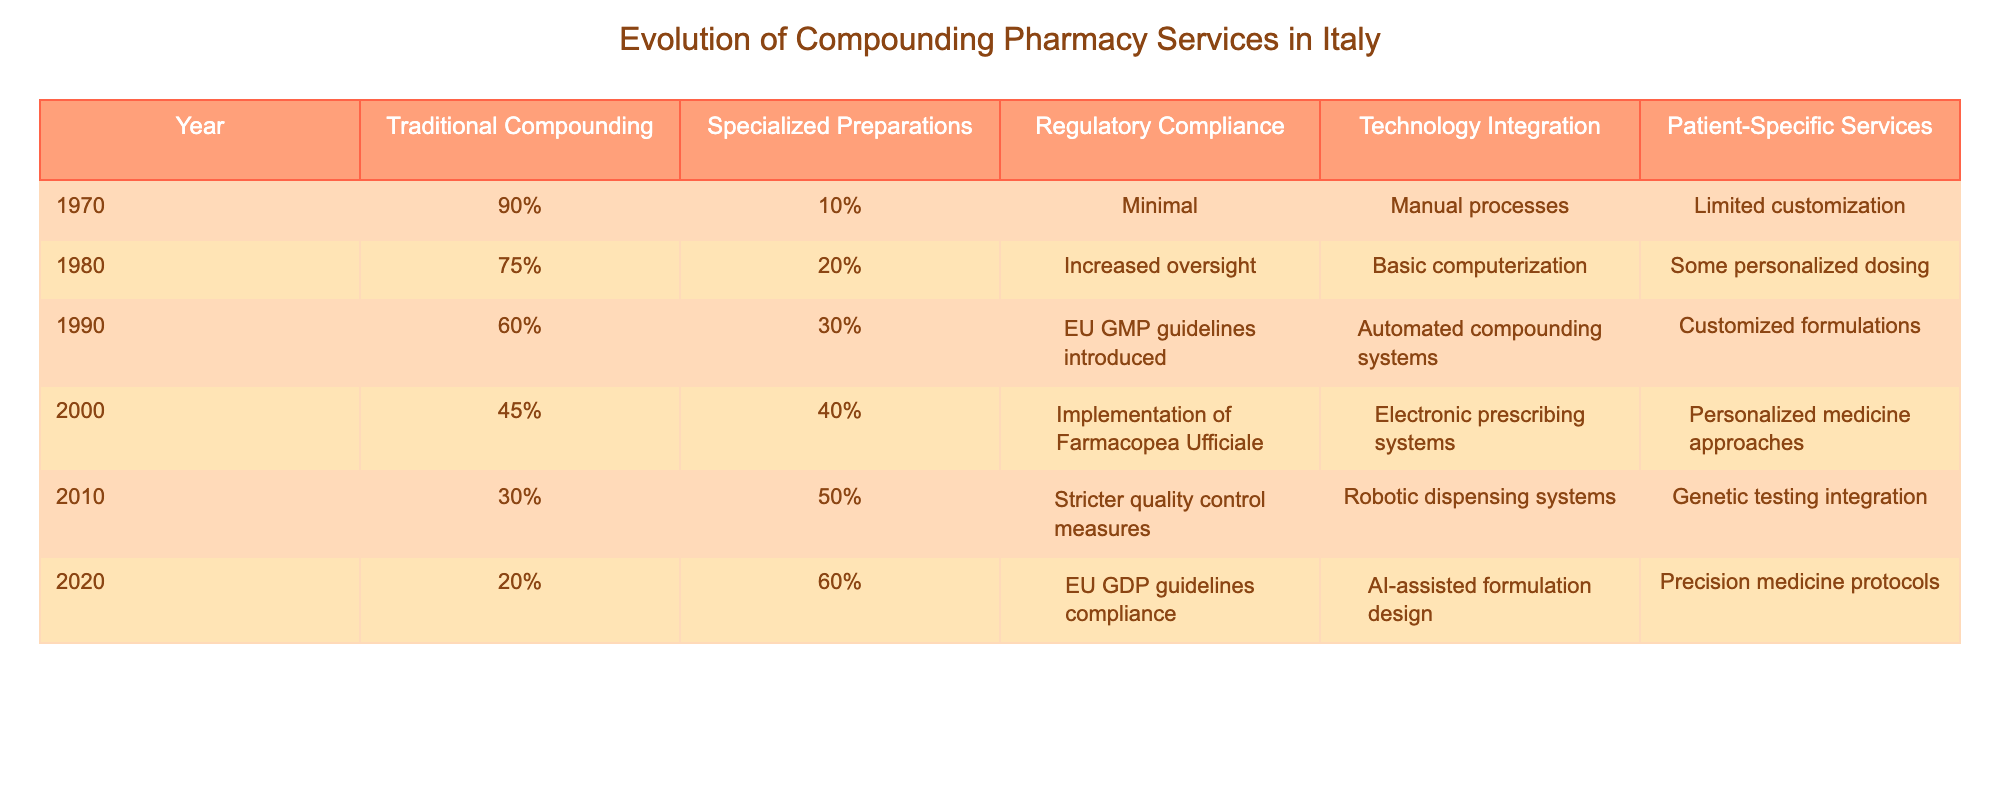What was the percentage of traditional compounding services in 1970? Referring to the table, in the year 1970, the percentage of traditional compounding services was listed as 90%.
Answer: 90% What percentage of pharmacy services were specialized preparations in 2010? In the year 2010, the table indicates that 50% of pharmacy services were specialized preparations.
Answer: 50% What is the trend of traditional compounding services from 1970 to 2020? By comparing the values from 1970 (90%) to 2020 (20%), we see a decreasing trend in traditional compounding services over the years.
Answer: Decreasing What was the percentage increase of specialized preparations from 2000 to 2020? The percentage of specialized preparations in 2000 was 40% and in 2020 it was 60%, so the increase is 60% - 40% = 20%.
Answer: 20% Did regulatory compliance measures increase over the years? Yes, examining the regulatory compliance column in the table shows an increase in oversight and compliance from minimal in 1970 to EU GDP guidelines by 2020.
Answer: Yes What was the difference in patient-specific services between 1990 and 2020? In 1990, patient-specific services were described as customized formulations, while in 2020 they were precision medicine protocols, indicating an evolution rather than a numerical difference.
Answer: Not applicable Which year saw the highest percentage of traditional compounding services? The highest percentage of traditional compounding services occurred in 1970, listed at 90%.
Answer: 1970 What percentage of pharmacy services were neither traditional compounding nor specialized preparations in 2020? In 2020, traditional compounding and specialized preparations accounted for 20% + 60% = 80%, leaving 20% that were neither.
Answer: 20% What can be said about the correlation between technology integration and patient-specific services over the years? As we observe the table, technology integration has increased over the years, from manual processes to AI-assisted formulation design, while patient-specific services evolved to precision medicine, indicating a positive correlation.
Answer: Positive correlation Was there a year where regulatory compliance measures were minimal? Yes, 1970 was the year that had minimal regulatory compliance measures according to the data provided in the table.
Answer: Yes 